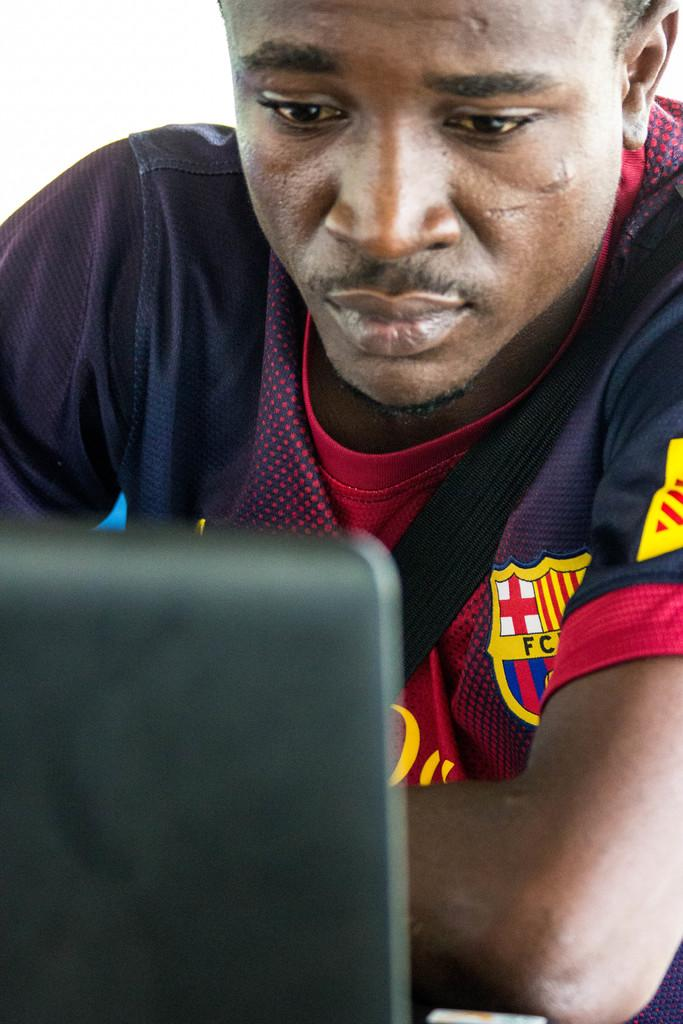<image>
Provide a brief description of the given image. A man wearing a shirt that has a crest with the letters FC on the chest looks at a computer. 